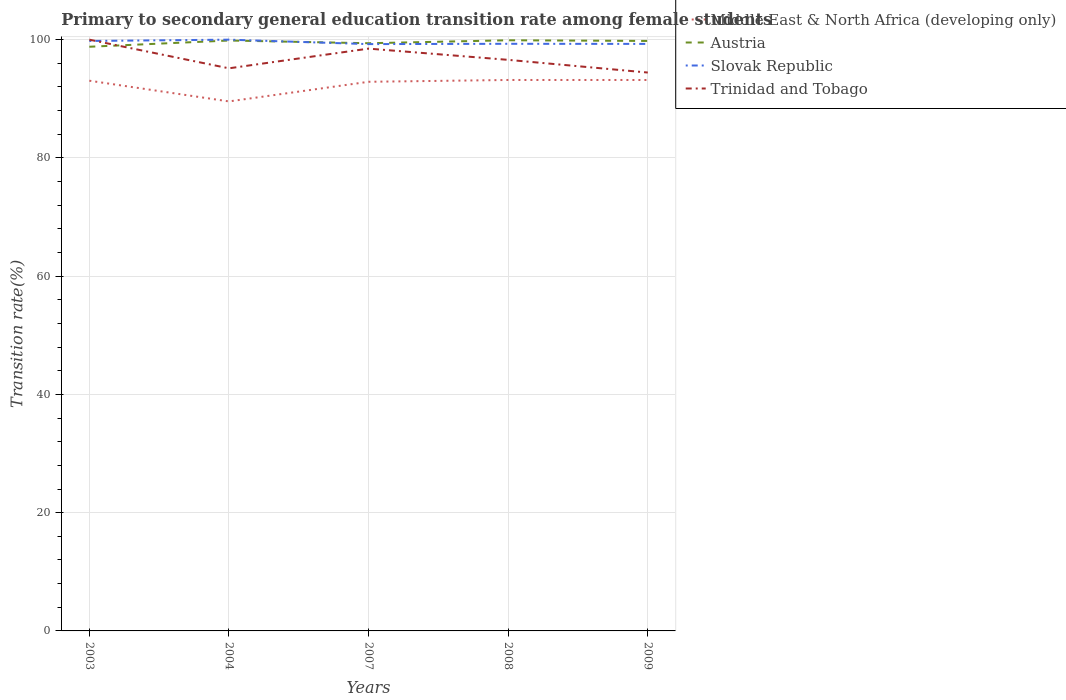How many different coloured lines are there?
Make the answer very short. 4. Across all years, what is the maximum transition rate in Slovak Republic?
Keep it short and to the point. 99.25. In which year was the transition rate in Austria maximum?
Provide a short and direct response. 2003. What is the total transition rate in Trinidad and Tobago in the graph?
Keep it short and to the point. 0.71. What is the difference between the highest and the second highest transition rate in Austria?
Give a very brief answer. 1.1. How many years are there in the graph?
Give a very brief answer. 5. What is the difference between two consecutive major ticks on the Y-axis?
Give a very brief answer. 20. Does the graph contain grids?
Your response must be concise. Yes. How are the legend labels stacked?
Keep it short and to the point. Vertical. What is the title of the graph?
Provide a short and direct response. Primary to secondary general education transition rate among female students. Does "Uganda" appear as one of the legend labels in the graph?
Your answer should be compact. No. What is the label or title of the Y-axis?
Provide a short and direct response. Transition rate(%). What is the Transition rate(%) in Middle East & North Africa (developing only) in 2003?
Make the answer very short. 93.06. What is the Transition rate(%) in Austria in 2003?
Your answer should be compact. 98.8. What is the Transition rate(%) in Slovak Republic in 2003?
Your answer should be compact. 99.78. What is the Transition rate(%) of Middle East & North Africa (developing only) in 2004?
Keep it short and to the point. 89.56. What is the Transition rate(%) of Austria in 2004?
Keep it short and to the point. 99.85. What is the Transition rate(%) in Trinidad and Tobago in 2004?
Provide a succinct answer. 95.15. What is the Transition rate(%) of Middle East & North Africa (developing only) in 2007?
Provide a short and direct response. 92.88. What is the Transition rate(%) in Austria in 2007?
Your response must be concise. 99.4. What is the Transition rate(%) in Slovak Republic in 2007?
Ensure brevity in your answer.  99.25. What is the Transition rate(%) of Trinidad and Tobago in 2007?
Provide a succinct answer. 98.48. What is the Transition rate(%) of Middle East & North Africa (developing only) in 2008?
Your response must be concise. 93.18. What is the Transition rate(%) in Austria in 2008?
Your answer should be very brief. 99.9. What is the Transition rate(%) in Slovak Republic in 2008?
Provide a short and direct response. 99.3. What is the Transition rate(%) in Trinidad and Tobago in 2008?
Keep it short and to the point. 96.58. What is the Transition rate(%) of Middle East & North Africa (developing only) in 2009?
Your answer should be very brief. 93.18. What is the Transition rate(%) of Austria in 2009?
Your answer should be compact. 99.78. What is the Transition rate(%) of Slovak Republic in 2009?
Keep it short and to the point. 99.28. What is the Transition rate(%) of Trinidad and Tobago in 2009?
Offer a terse response. 94.44. Across all years, what is the maximum Transition rate(%) in Middle East & North Africa (developing only)?
Provide a succinct answer. 93.18. Across all years, what is the maximum Transition rate(%) of Austria?
Ensure brevity in your answer.  99.9. Across all years, what is the maximum Transition rate(%) of Slovak Republic?
Ensure brevity in your answer.  100. Across all years, what is the minimum Transition rate(%) in Middle East & North Africa (developing only)?
Provide a succinct answer. 89.56. Across all years, what is the minimum Transition rate(%) in Austria?
Make the answer very short. 98.8. Across all years, what is the minimum Transition rate(%) in Slovak Republic?
Provide a short and direct response. 99.25. Across all years, what is the minimum Transition rate(%) in Trinidad and Tobago?
Ensure brevity in your answer.  94.44. What is the total Transition rate(%) in Middle East & North Africa (developing only) in the graph?
Offer a very short reply. 461.85. What is the total Transition rate(%) in Austria in the graph?
Offer a very short reply. 497.73. What is the total Transition rate(%) in Slovak Republic in the graph?
Keep it short and to the point. 497.61. What is the total Transition rate(%) in Trinidad and Tobago in the graph?
Keep it short and to the point. 484.66. What is the difference between the Transition rate(%) of Middle East & North Africa (developing only) in 2003 and that in 2004?
Your answer should be compact. 3.5. What is the difference between the Transition rate(%) in Austria in 2003 and that in 2004?
Offer a very short reply. -1.05. What is the difference between the Transition rate(%) of Slovak Republic in 2003 and that in 2004?
Keep it short and to the point. -0.22. What is the difference between the Transition rate(%) in Trinidad and Tobago in 2003 and that in 2004?
Your response must be concise. 4.85. What is the difference between the Transition rate(%) of Middle East & North Africa (developing only) in 2003 and that in 2007?
Offer a terse response. 0.18. What is the difference between the Transition rate(%) of Austria in 2003 and that in 2007?
Offer a very short reply. -0.6. What is the difference between the Transition rate(%) in Slovak Republic in 2003 and that in 2007?
Offer a very short reply. 0.53. What is the difference between the Transition rate(%) in Trinidad and Tobago in 2003 and that in 2007?
Offer a very short reply. 1.52. What is the difference between the Transition rate(%) of Middle East & North Africa (developing only) in 2003 and that in 2008?
Your answer should be very brief. -0.12. What is the difference between the Transition rate(%) of Austria in 2003 and that in 2008?
Give a very brief answer. -1.1. What is the difference between the Transition rate(%) in Slovak Republic in 2003 and that in 2008?
Provide a succinct answer. 0.48. What is the difference between the Transition rate(%) in Trinidad and Tobago in 2003 and that in 2008?
Provide a succinct answer. 3.42. What is the difference between the Transition rate(%) of Middle East & North Africa (developing only) in 2003 and that in 2009?
Offer a terse response. -0.12. What is the difference between the Transition rate(%) of Austria in 2003 and that in 2009?
Provide a short and direct response. -0.98. What is the difference between the Transition rate(%) of Slovak Republic in 2003 and that in 2009?
Offer a terse response. 0.5. What is the difference between the Transition rate(%) in Trinidad and Tobago in 2003 and that in 2009?
Provide a short and direct response. 5.56. What is the difference between the Transition rate(%) in Middle East & North Africa (developing only) in 2004 and that in 2007?
Provide a short and direct response. -3.32. What is the difference between the Transition rate(%) in Austria in 2004 and that in 2007?
Make the answer very short. 0.46. What is the difference between the Transition rate(%) of Slovak Republic in 2004 and that in 2007?
Give a very brief answer. 0.75. What is the difference between the Transition rate(%) of Trinidad and Tobago in 2004 and that in 2007?
Make the answer very short. -3.33. What is the difference between the Transition rate(%) in Middle East & North Africa (developing only) in 2004 and that in 2008?
Your response must be concise. -3.63. What is the difference between the Transition rate(%) of Austria in 2004 and that in 2008?
Provide a short and direct response. -0.04. What is the difference between the Transition rate(%) in Slovak Republic in 2004 and that in 2008?
Provide a short and direct response. 0.7. What is the difference between the Transition rate(%) of Trinidad and Tobago in 2004 and that in 2008?
Your response must be concise. -1.43. What is the difference between the Transition rate(%) in Middle East & North Africa (developing only) in 2004 and that in 2009?
Your response must be concise. -3.62. What is the difference between the Transition rate(%) of Austria in 2004 and that in 2009?
Your answer should be compact. 0.07. What is the difference between the Transition rate(%) of Slovak Republic in 2004 and that in 2009?
Your answer should be very brief. 0.72. What is the difference between the Transition rate(%) of Trinidad and Tobago in 2004 and that in 2009?
Offer a terse response. 0.71. What is the difference between the Transition rate(%) in Middle East & North Africa (developing only) in 2007 and that in 2008?
Offer a terse response. -0.31. What is the difference between the Transition rate(%) in Austria in 2007 and that in 2008?
Keep it short and to the point. -0.5. What is the difference between the Transition rate(%) of Slovak Republic in 2007 and that in 2008?
Provide a succinct answer. -0.05. What is the difference between the Transition rate(%) of Trinidad and Tobago in 2007 and that in 2008?
Provide a short and direct response. 1.9. What is the difference between the Transition rate(%) in Middle East & North Africa (developing only) in 2007 and that in 2009?
Provide a succinct answer. -0.3. What is the difference between the Transition rate(%) of Austria in 2007 and that in 2009?
Ensure brevity in your answer.  -0.39. What is the difference between the Transition rate(%) in Slovak Republic in 2007 and that in 2009?
Ensure brevity in your answer.  -0.03. What is the difference between the Transition rate(%) of Trinidad and Tobago in 2007 and that in 2009?
Provide a short and direct response. 4.05. What is the difference between the Transition rate(%) in Middle East & North Africa (developing only) in 2008 and that in 2009?
Offer a terse response. 0. What is the difference between the Transition rate(%) of Austria in 2008 and that in 2009?
Your response must be concise. 0.11. What is the difference between the Transition rate(%) of Slovak Republic in 2008 and that in 2009?
Your response must be concise. 0.02. What is the difference between the Transition rate(%) of Trinidad and Tobago in 2008 and that in 2009?
Offer a terse response. 2.15. What is the difference between the Transition rate(%) of Middle East & North Africa (developing only) in 2003 and the Transition rate(%) of Austria in 2004?
Offer a very short reply. -6.8. What is the difference between the Transition rate(%) of Middle East & North Africa (developing only) in 2003 and the Transition rate(%) of Slovak Republic in 2004?
Ensure brevity in your answer.  -6.94. What is the difference between the Transition rate(%) in Middle East & North Africa (developing only) in 2003 and the Transition rate(%) in Trinidad and Tobago in 2004?
Ensure brevity in your answer.  -2.1. What is the difference between the Transition rate(%) of Austria in 2003 and the Transition rate(%) of Slovak Republic in 2004?
Offer a terse response. -1.2. What is the difference between the Transition rate(%) in Austria in 2003 and the Transition rate(%) in Trinidad and Tobago in 2004?
Give a very brief answer. 3.65. What is the difference between the Transition rate(%) of Slovak Republic in 2003 and the Transition rate(%) of Trinidad and Tobago in 2004?
Your answer should be compact. 4.63. What is the difference between the Transition rate(%) in Middle East & North Africa (developing only) in 2003 and the Transition rate(%) in Austria in 2007?
Your answer should be compact. -6.34. What is the difference between the Transition rate(%) of Middle East & North Africa (developing only) in 2003 and the Transition rate(%) of Slovak Republic in 2007?
Provide a succinct answer. -6.19. What is the difference between the Transition rate(%) in Middle East & North Africa (developing only) in 2003 and the Transition rate(%) in Trinidad and Tobago in 2007?
Keep it short and to the point. -5.43. What is the difference between the Transition rate(%) of Austria in 2003 and the Transition rate(%) of Slovak Republic in 2007?
Your answer should be very brief. -0.45. What is the difference between the Transition rate(%) in Austria in 2003 and the Transition rate(%) in Trinidad and Tobago in 2007?
Ensure brevity in your answer.  0.32. What is the difference between the Transition rate(%) of Slovak Republic in 2003 and the Transition rate(%) of Trinidad and Tobago in 2007?
Provide a succinct answer. 1.29. What is the difference between the Transition rate(%) in Middle East & North Africa (developing only) in 2003 and the Transition rate(%) in Austria in 2008?
Offer a terse response. -6.84. What is the difference between the Transition rate(%) in Middle East & North Africa (developing only) in 2003 and the Transition rate(%) in Slovak Republic in 2008?
Offer a terse response. -6.24. What is the difference between the Transition rate(%) of Middle East & North Africa (developing only) in 2003 and the Transition rate(%) of Trinidad and Tobago in 2008?
Your answer should be compact. -3.53. What is the difference between the Transition rate(%) in Austria in 2003 and the Transition rate(%) in Slovak Republic in 2008?
Provide a succinct answer. -0.5. What is the difference between the Transition rate(%) of Austria in 2003 and the Transition rate(%) of Trinidad and Tobago in 2008?
Offer a very short reply. 2.22. What is the difference between the Transition rate(%) in Slovak Republic in 2003 and the Transition rate(%) in Trinidad and Tobago in 2008?
Provide a short and direct response. 3.19. What is the difference between the Transition rate(%) of Middle East & North Africa (developing only) in 2003 and the Transition rate(%) of Austria in 2009?
Provide a short and direct response. -6.73. What is the difference between the Transition rate(%) of Middle East & North Africa (developing only) in 2003 and the Transition rate(%) of Slovak Republic in 2009?
Make the answer very short. -6.22. What is the difference between the Transition rate(%) in Middle East & North Africa (developing only) in 2003 and the Transition rate(%) in Trinidad and Tobago in 2009?
Make the answer very short. -1.38. What is the difference between the Transition rate(%) of Austria in 2003 and the Transition rate(%) of Slovak Republic in 2009?
Give a very brief answer. -0.48. What is the difference between the Transition rate(%) in Austria in 2003 and the Transition rate(%) in Trinidad and Tobago in 2009?
Offer a very short reply. 4.36. What is the difference between the Transition rate(%) in Slovak Republic in 2003 and the Transition rate(%) in Trinidad and Tobago in 2009?
Ensure brevity in your answer.  5.34. What is the difference between the Transition rate(%) in Middle East & North Africa (developing only) in 2004 and the Transition rate(%) in Austria in 2007?
Offer a very short reply. -9.84. What is the difference between the Transition rate(%) in Middle East & North Africa (developing only) in 2004 and the Transition rate(%) in Slovak Republic in 2007?
Offer a terse response. -9.69. What is the difference between the Transition rate(%) of Middle East & North Africa (developing only) in 2004 and the Transition rate(%) of Trinidad and Tobago in 2007?
Your answer should be very brief. -8.93. What is the difference between the Transition rate(%) of Austria in 2004 and the Transition rate(%) of Slovak Republic in 2007?
Keep it short and to the point. 0.61. What is the difference between the Transition rate(%) of Austria in 2004 and the Transition rate(%) of Trinidad and Tobago in 2007?
Your response must be concise. 1.37. What is the difference between the Transition rate(%) of Slovak Republic in 2004 and the Transition rate(%) of Trinidad and Tobago in 2007?
Your answer should be compact. 1.52. What is the difference between the Transition rate(%) of Middle East & North Africa (developing only) in 2004 and the Transition rate(%) of Austria in 2008?
Give a very brief answer. -10.34. What is the difference between the Transition rate(%) in Middle East & North Africa (developing only) in 2004 and the Transition rate(%) in Slovak Republic in 2008?
Your answer should be very brief. -9.74. What is the difference between the Transition rate(%) in Middle East & North Africa (developing only) in 2004 and the Transition rate(%) in Trinidad and Tobago in 2008?
Give a very brief answer. -7.03. What is the difference between the Transition rate(%) of Austria in 2004 and the Transition rate(%) of Slovak Republic in 2008?
Provide a succinct answer. 0.56. What is the difference between the Transition rate(%) of Austria in 2004 and the Transition rate(%) of Trinidad and Tobago in 2008?
Keep it short and to the point. 3.27. What is the difference between the Transition rate(%) in Slovak Republic in 2004 and the Transition rate(%) in Trinidad and Tobago in 2008?
Give a very brief answer. 3.42. What is the difference between the Transition rate(%) of Middle East & North Africa (developing only) in 2004 and the Transition rate(%) of Austria in 2009?
Provide a short and direct response. -10.23. What is the difference between the Transition rate(%) of Middle East & North Africa (developing only) in 2004 and the Transition rate(%) of Slovak Republic in 2009?
Your answer should be compact. -9.73. What is the difference between the Transition rate(%) of Middle East & North Africa (developing only) in 2004 and the Transition rate(%) of Trinidad and Tobago in 2009?
Make the answer very short. -4.88. What is the difference between the Transition rate(%) in Austria in 2004 and the Transition rate(%) in Slovak Republic in 2009?
Provide a short and direct response. 0.57. What is the difference between the Transition rate(%) of Austria in 2004 and the Transition rate(%) of Trinidad and Tobago in 2009?
Keep it short and to the point. 5.42. What is the difference between the Transition rate(%) in Slovak Republic in 2004 and the Transition rate(%) in Trinidad and Tobago in 2009?
Keep it short and to the point. 5.56. What is the difference between the Transition rate(%) of Middle East & North Africa (developing only) in 2007 and the Transition rate(%) of Austria in 2008?
Your response must be concise. -7.02. What is the difference between the Transition rate(%) of Middle East & North Africa (developing only) in 2007 and the Transition rate(%) of Slovak Republic in 2008?
Provide a succinct answer. -6.42. What is the difference between the Transition rate(%) of Middle East & North Africa (developing only) in 2007 and the Transition rate(%) of Trinidad and Tobago in 2008?
Provide a short and direct response. -3.71. What is the difference between the Transition rate(%) in Austria in 2007 and the Transition rate(%) in Slovak Republic in 2008?
Offer a very short reply. 0.1. What is the difference between the Transition rate(%) in Austria in 2007 and the Transition rate(%) in Trinidad and Tobago in 2008?
Your answer should be very brief. 2.81. What is the difference between the Transition rate(%) of Slovak Republic in 2007 and the Transition rate(%) of Trinidad and Tobago in 2008?
Your response must be concise. 2.66. What is the difference between the Transition rate(%) in Middle East & North Africa (developing only) in 2007 and the Transition rate(%) in Austria in 2009?
Offer a very short reply. -6.91. What is the difference between the Transition rate(%) in Middle East & North Africa (developing only) in 2007 and the Transition rate(%) in Slovak Republic in 2009?
Ensure brevity in your answer.  -6.41. What is the difference between the Transition rate(%) in Middle East & North Africa (developing only) in 2007 and the Transition rate(%) in Trinidad and Tobago in 2009?
Ensure brevity in your answer.  -1.56. What is the difference between the Transition rate(%) of Austria in 2007 and the Transition rate(%) of Slovak Republic in 2009?
Your answer should be very brief. 0.12. What is the difference between the Transition rate(%) of Austria in 2007 and the Transition rate(%) of Trinidad and Tobago in 2009?
Your answer should be very brief. 4.96. What is the difference between the Transition rate(%) in Slovak Republic in 2007 and the Transition rate(%) in Trinidad and Tobago in 2009?
Ensure brevity in your answer.  4.81. What is the difference between the Transition rate(%) in Middle East & North Africa (developing only) in 2008 and the Transition rate(%) in Austria in 2009?
Offer a terse response. -6.6. What is the difference between the Transition rate(%) in Middle East & North Africa (developing only) in 2008 and the Transition rate(%) in Slovak Republic in 2009?
Offer a very short reply. -6.1. What is the difference between the Transition rate(%) in Middle East & North Africa (developing only) in 2008 and the Transition rate(%) in Trinidad and Tobago in 2009?
Make the answer very short. -1.26. What is the difference between the Transition rate(%) in Austria in 2008 and the Transition rate(%) in Slovak Republic in 2009?
Offer a very short reply. 0.62. What is the difference between the Transition rate(%) in Austria in 2008 and the Transition rate(%) in Trinidad and Tobago in 2009?
Provide a short and direct response. 5.46. What is the difference between the Transition rate(%) in Slovak Republic in 2008 and the Transition rate(%) in Trinidad and Tobago in 2009?
Provide a succinct answer. 4.86. What is the average Transition rate(%) of Middle East & North Africa (developing only) per year?
Provide a short and direct response. 92.37. What is the average Transition rate(%) in Austria per year?
Your answer should be compact. 99.55. What is the average Transition rate(%) of Slovak Republic per year?
Provide a short and direct response. 99.52. What is the average Transition rate(%) of Trinidad and Tobago per year?
Your response must be concise. 96.93. In the year 2003, what is the difference between the Transition rate(%) in Middle East & North Africa (developing only) and Transition rate(%) in Austria?
Provide a succinct answer. -5.74. In the year 2003, what is the difference between the Transition rate(%) in Middle East & North Africa (developing only) and Transition rate(%) in Slovak Republic?
Give a very brief answer. -6.72. In the year 2003, what is the difference between the Transition rate(%) of Middle East & North Africa (developing only) and Transition rate(%) of Trinidad and Tobago?
Your answer should be very brief. -6.94. In the year 2003, what is the difference between the Transition rate(%) of Austria and Transition rate(%) of Slovak Republic?
Give a very brief answer. -0.98. In the year 2003, what is the difference between the Transition rate(%) in Austria and Transition rate(%) in Trinidad and Tobago?
Provide a short and direct response. -1.2. In the year 2003, what is the difference between the Transition rate(%) of Slovak Republic and Transition rate(%) of Trinidad and Tobago?
Give a very brief answer. -0.22. In the year 2004, what is the difference between the Transition rate(%) of Middle East & North Africa (developing only) and Transition rate(%) of Austria?
Ensure brevity in your answer.  -10.3. In the year 2004, what is the difference between the Transition rate(%) in Middle East & North Africa (developing only) and Transition rate(%) in Slovak Republic?
Make the answer very short. -10.44. In the year 2004, what is the difference between the Transition rate(%) of Middle East & North Africa (developing only) and Transition rate(%) of Trinidad and Tobago?
Ensure brevity in your answer.  -5.6. In the year 2004, what is the difference between the Transition rate(%) of Austria and Transition rate(%) of Slovak Republic?
Your answer should be very brief. -0.15. In the year 2004, what is the difference between the Transition rate(%) in Austria and Transition rate(%) in Trinidad and Tobago?
Your answer should be compact. 4.7. In the year 2004, what is the difference between the Transition rate(%) in Slovak Republic and Transition rate(%) in Trinidad and Tobago?
Make the answer very short. 4.85. In the year 2007, what is the difference between the Transition rate(%) in Middle East & North Africa (developing only) and Transition rate(%) in Austria?
Provide a succinct answer. -6.52. In the year 2007, what is the difference between the Transition rate(%) in Middle East & North Africa (developing only) and Transition rate(%) in Slovak Republic?
Give a very brief answer. -6.37. In the year 2007, what is the difference between the Transition rate(%) of Middle East & North Africa (developing only) and Transition rate(%) of Trinidad and Tobago?
Make the answer very short. -5.61. In the year 2007, what is the difference between the Transition rate(%) of Austria and Transition rate(%) of Slovak Republic?
Your response must be concise. 0.15. In the year 2007, what is the difference between the Transition rate(%) of Austria and Transition rate(%) of Trinidad and Tobago?
Your response must be concise. 0.91. In the year 2007, what is the difference between the Transition rate(%) in Slovak Republic and Transition rate(%) in Trinidad and Tobago?
Offer a terse response. 0.76. In the year 2008, what is the difference between the Transition rate(%) in Middle East & North Africa (developing only) and Transition rate(%) in Austria?
Your response must be concise. -6.72. In the year 2008, what is the difference between the Transition rate(%) in Middle East & North Africa (developing only) and Transition rate(%) in Slovak Republic?
Your answer should be very brief. -6.12. In the year 2008, what is the difference between the Transition rate(%) in Middle East & North Africa (developing only) and Transition rate(%) in Trinidad and Tobago?
Provide a short and direct response. -3.4. In the year 2008, what is the difference between the Transition rate(%) of Austria and Transition rate(%) of Slovak Republic?
Give a very brief answer. 0.6. In the year 2008, what is the difference between the Transition rate(%) in Austria and Transition rate(%) in Trinidad and Tobago?
Ensure brevity in your answer.  3.31. In the year 2008, what is the difference between the Transition rate(%) of Slovak Republic and Transition rate(%) of Trinidad and Tobago?
Your answer should be compact. 2.72. In the year 2009, what is the difference between the Transition rate(%) in Middle East & North Africa (developing only) and Transition rate(%) in Austria?
Give a very brief answer. -6.61. In the year 2009, what is the difference between the Transition rate(%) of Middle East & North Africa (developing only) and Transition rate(%) of Slovak Republic?
Ensure brevity in your answer.  -6.1. In the year 2009, what is the difference between the Transition rate(%) in Middle East & North Africa (developing only) and Transition rate(%) in Trinidad and Tobago?
Your answer should be very brief. -1.26. In the year 2009, what is the difference between the Transition rate(%) of Austria and Transition rate(%) of Slovak Republic?
Keep it short and to the point. 0.5. In the year 2009, what is the difference between the Transition rate(%) in Austria and Transition rate(%) in Trinidad and Tobago?
Provide a succinct answer. 5.34. In the year 2009, what is the difference between the Transition rate(%) in Slovak Republic and Transition rate(%) in Trinidad and Tobago?
Keep it short and to the point. 4.84. What is the ratio of the Transition rate(%) of Middle East & North Africa (developing only) in 2003 to that in 2004?
Offer a terse response. 1.04. What is the ratio of the Transition rate(%) of Austria in 2003 to that in 2004?
Ensure brevity in your answer.  0.99. What is the ratio of the Transition rate(%) in Slovak Republic in 2003 to that in 2004?
Offer a terse response. 1. What is the ratio of the Transition rate(%) of Trinidad and Tobago in 2003 to that in 2004?
Your answer should be very brief. 1.05. What is the ratio of the Transition rate(%) of Middle East & North Africa (developing only) in 2003 to that in 2007?
Make the answer very short. 1. What is the ratio of the Transition rate(%) of Austria in 2003 to that in 2007?
Your response must be concise. 0.99. What is the ratio of the Transition rate(%) in Slovak Republic in 2003 to that in 2007?
Provide a short and direct response. 1.01. What is the ratio of the Transition rate(%) of Trinidad and Tobago in 2003 to that in 2007?
Ensure brevity in your answer.  1.02. What is the ratio of the Transition rate(%) of Trinidad and Tobago in 2003 to that in 2008?
Make the answer very short. 1.04. What is the ratio of the Transition rate(%) in Middle East & North Africa (developing only) in 2003 to that in 2009?
Offer a terse response. 1. What is the ratio of the Transition rate(%) of Austria in 2003 to that in 2009?
Provide a succinct answer. 0.99. What is the ratio of the Transition rate(%) of Trinidad and Tobago in 2003 to that in 2009?
Offer a terse response. 1.06. What is the ratio of the Transition rate(%) in Austria in 2004 to that in 2007?
Make the answer very short. 1. What is the ratio of the Transition rate(%) in Slovak Republic in 2004 to that in 2007?
Give a very brief answer. 1.01. What is the ratio of the Transition rate(%) of Trinidad and Tobago in 2004 to that in 2007?
Your answer should be very brief. 0.97. What is the ratio of the Transition rate(%) of Middle East & North Africa (developing only) in 2004 to that in 2008?
Make the answer very short. 0.96. What is the ratio of the Transition rate(%) of Austria in 2004 to that in 2008?
Your response must be concise. 1. What is the ratio of the Transition rate(%) of Slovak Republic in 2004 to that in 2008?
Keep it short and to the point. 1.01. What is the ratio of the Transition rate(%) of Trinidad and Tobago in 2004 to that in 2008?
Offer a very short reply. 0.99. What is the ratio of the Transition rate(%) of Middle East & North Africa (developing only) in 2004 to that in 2009?
Ensure brevity in your answer.  0.96. What is the ratio of the Transition rate(%) of Slovak Republic in 2004 to that in 2009?
Make the answer very short. 1.01. What is the ratio of the Transition rate(%) of Trinidad and Tobago in 2004 to that in 2009?
Provide a succinct answer. 1.01. What is the ratio of the Transition rate(%) of Austria in 2007 to that in 2008?
Provide a succinct answer. 0.99. What is the ratio of the Transition rate(%) of Slovak Republic in 2007 to that in 2008?
Keep it short and to the point. 1. What is the ratio of the Transition rate(%) of Trinidad and Tobago in 2007 to that in 2008?
Give a very brief answer. 1.02. What is the ratio of the Transition rate(%) in Slovak Republic in 2007 to that in 2009?
Provide a short and direct response. 1. What is the ratio of the Transition rate(%) in Trinidad and Tobago in 2007 to that in 2009?
Give a very brief answer. 1.04. What is the ratio of the Transition rate(%) in Trinidad and Tobago in 2008 to that in 2009?
Offer a very short reply. 1.02. What is the difference between the highest and the second highest Transition rate(%) of Middle East & North Africa (developing only)?
Your answer should be very brief. 0. What is the difference between the highest and the second highest Transition rate(%) of Austria?
Keep it short and to the point. 0.04. What is the difference between the highest and the second highest Transition rate(%) of Slovak Republic?
Your response must be concise. 0.22. What is the difference between the highest and the second highest Transition rate(%) of Trinidad and Tobago?
Ensure brevity in your answer.  1.52. What is the difference between the highest and the lowest Transition rate(%) in Middle East & North Africa (developing only)?
Keep it short and to the point. 3.63. What is the difference between the highest and the lowest Transition rate(%) in Austria?
Give a very brief answer. 1.1. What is the difference between the highest and the lowest Transition rate(%) in Slovak Republic?
Your answer should be compact. 0.75. What is the difference between the highest and the lowest Transition rate(%) in Trinidad and Tobago?
Your answer should be very brief. 5.56. 